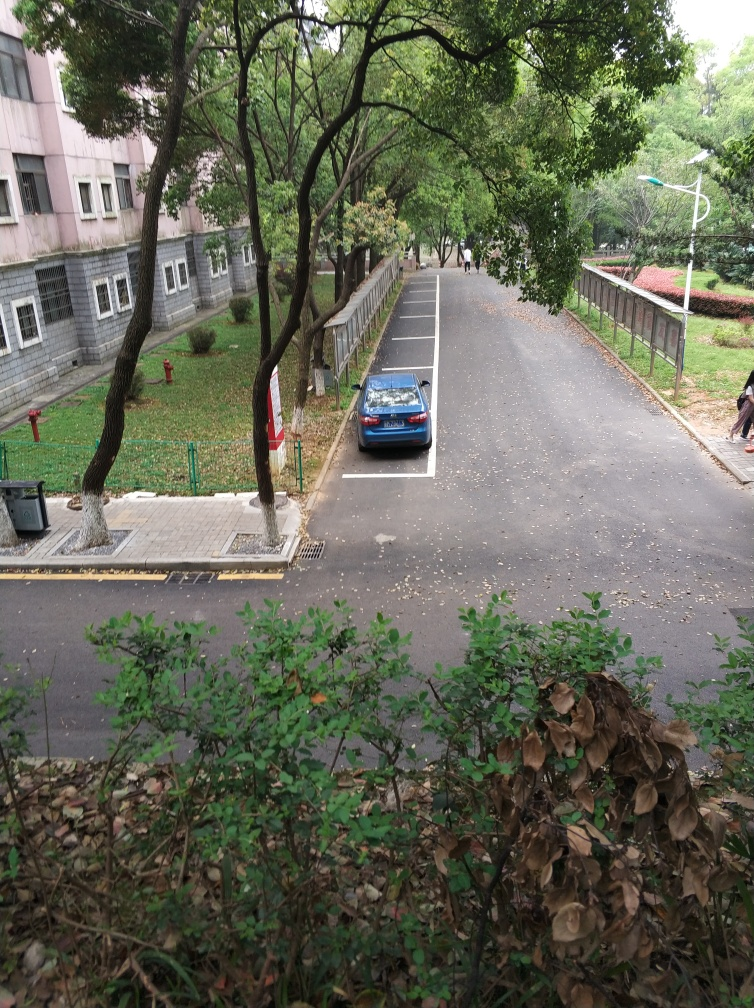Is this area meant for pedestrians or vehicles, and how can you tell? The area appears to cater to both pedestrians and vehicles. You can see that the wide pavement on the right is designed for pedestrian use, while the marked parking spaces and driveway surface indicate areas intended for vehicles. 